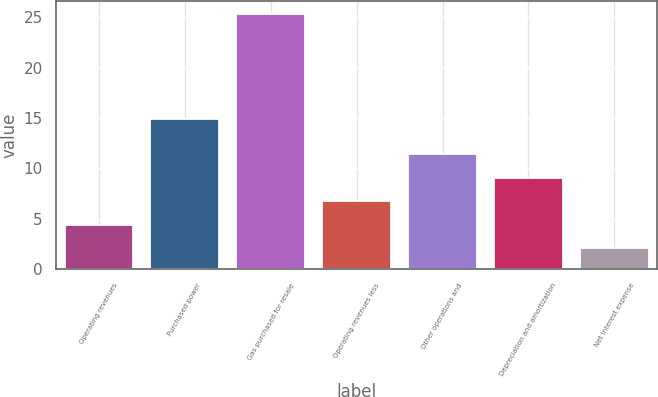<chart> <loc_0><loc_0><loc_500><loc_500><bar_chart><fcel>Operating revenues<fcel>Purchased power<fcel>Gas purchased for resale<fcel>Operating revenues less<fcel>Other operations and<fcel>Depreciation and amortization<fcel>Net interest expense<nl><fcel>4.42<fcel>14.9<fcel>25.3<fcel>6.74<fcel>11.38<fcel>9.06<fcel>2.1<nl></chart> 